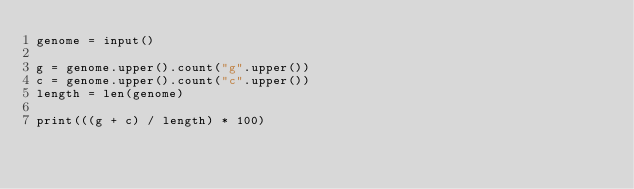<code> <loc_0><loc_0><loc_500><loc_500><_Python_>genome = input()

g = genome.upper().count("g".upper())
c = genome.upper().count("c".upper())
length = len(genome)

print(((g + c) / length) * 100)
</code> 